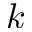<formula> <loc_0><loc_0><loc_500><loc_500>k</formula> 